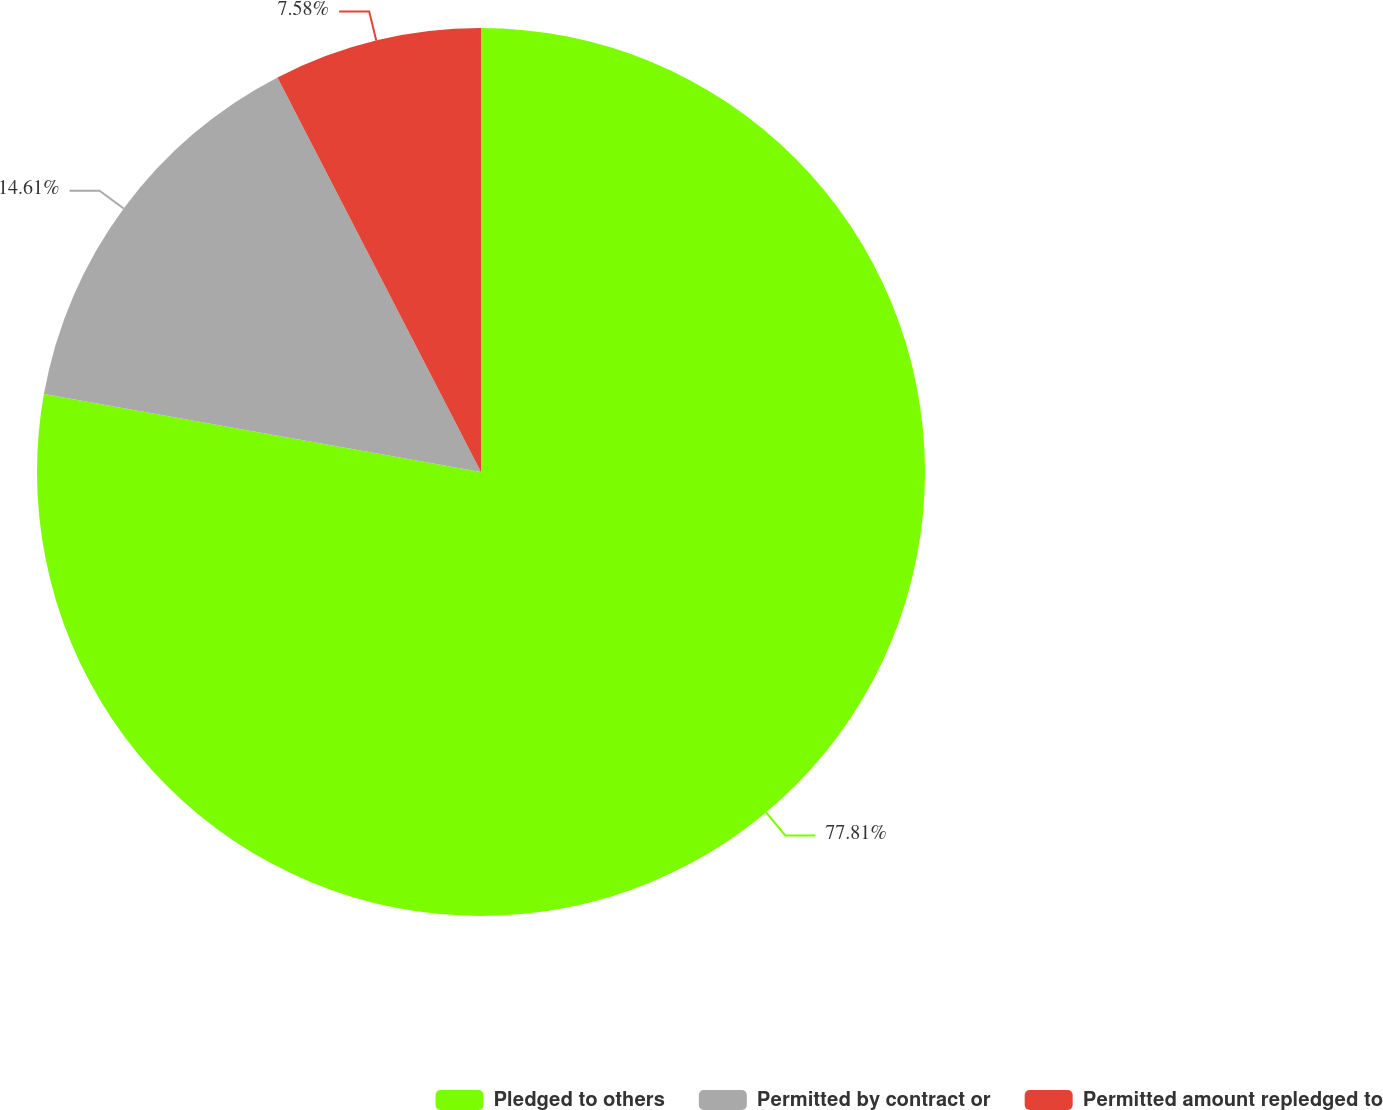Convert chart to OTSL. <chart><loc_0><loc_0><loc_500><loc_500><pie_chart><fcel>Pledged to others<fcel>Permitted by contract or<fcel>Permitted amount repledged to<nl><fcel>77.81%<fcel>14.61%<fcel>7.58%<nl></chart> 